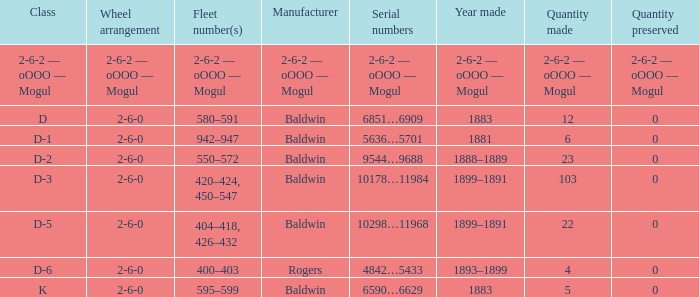Give me the full table as a dictionary. {'header': ['Class', 'Wheel arrangement', 'Fleet number(s)', 'Manufacturer', 'Serial numbers', 'Year made', 'Quantity made', 'Quantity preserved'], 'rows': [['2-6-2 — oOOO — Mogul', '2-6-2 — oOOO — Mogul', '2-6-2 — oOOO — Mogul', '2-6-2 — oOOO — Mogul', '2-6-2 — oOOO — Mogul', '2-6-2 — oOOO — Mogul', '2-6-2 — oOOO — Mogul', '2-6-2 — oOOO — Mogul'], ['D', '2-6-0', '580–591', 'Baldwin', '6851…6909', '1883', '12', '0'], ['D-1', '2-6-0', '942–947', 'Baldwin', '5636…5701', '1881', '6', '0'], ['D-2', '2-6-0', '550–572', 'Baldwin', '9544…9688', '1888–1889', '23', '0'], ['D-3', '2-6-0', '420–424, 450–547', 'Baldwin', '10178…11984', '1899–1891', '103', '0'], ['D-5', '2-6-0', '404–418, 426–432', 'Baldwin', '10298…11968', '1899–1891', '22', '0'], ['D-6', '2-6-0', '400–403', 'Rogers', '4842…5433', '1893–1899', '4', '0'], ['K', '2-6-0', '595–599', 'Baldwin', '6590…6629', '1883', '5', '0']]} What is the creation year when the producer is 2-6-2 — oooo — mogul? 2-6-2 — oOOO — Mogul. 